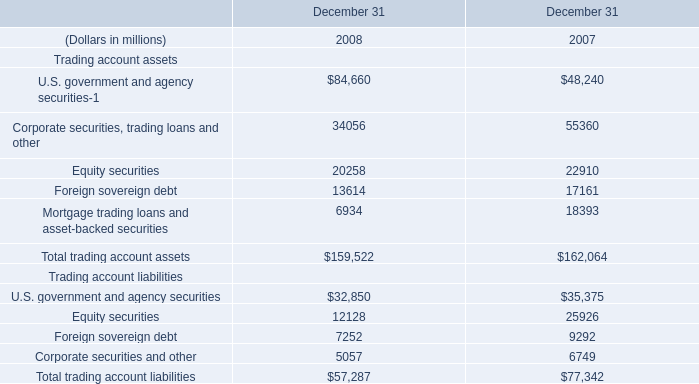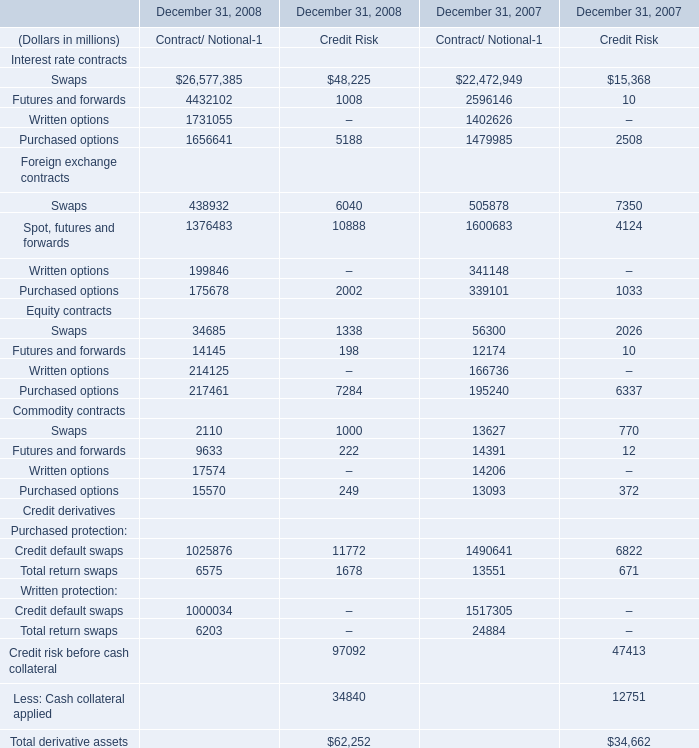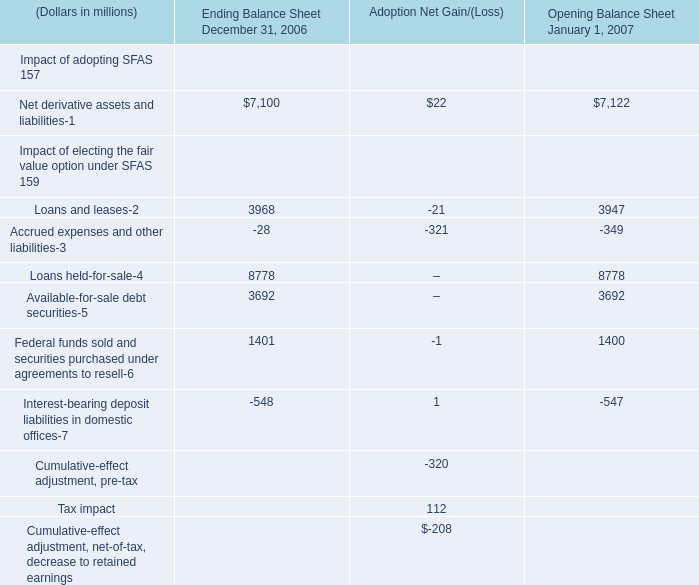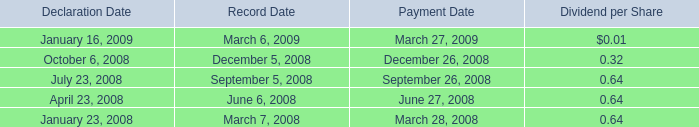What's the average of U.S. government and agency securities and Corporate securities, trading loans and other and Equity securities in 2008? (in miilion) 
Computations: (((84660 + 34056) + 20258) / 3)
Answer: 46324.66667. 